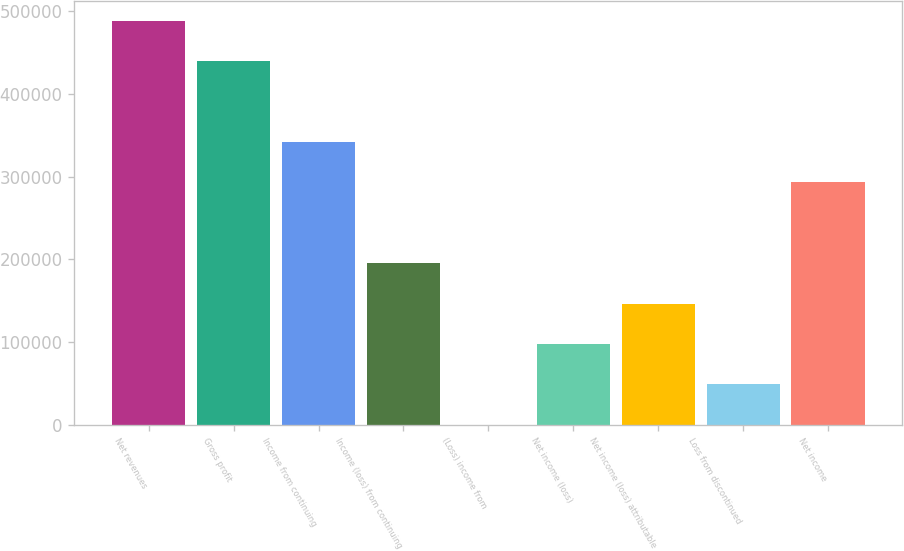<chart> <loc_0><loc_0><loc_500><loc_500><bar_chart><fcel>Net revenues<fcel>Gross profit<fcel>Income from continuing<fcel>Income (loss) from continuing<fcel>(Loss) income from<fcel>Net income (loss)<fcel>Net income (loss) attributable<fcel>Loss from discontinued<fcel>Net income<nl><fcel>487881<fcel>439111<fcel>341570<fcel>195260<fcel>179<fcel>97719.4<fcel>146490<fcel>48949.2<fcel>292800<nl></chart> 